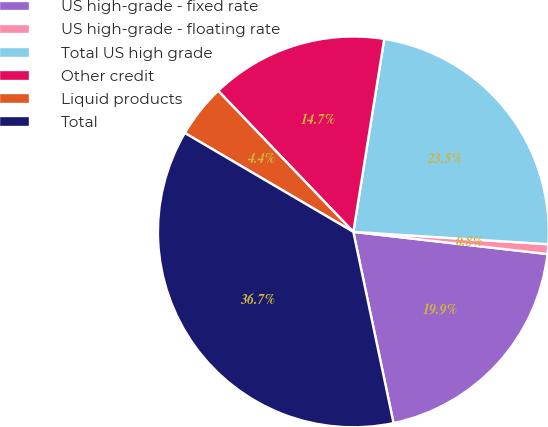Convert chart. <chart><loc_0><loc_0><loc_500><loc_500><pie_chart><fcel>US high-grade - fixed rate<fcel>US high-grade - floating rate<fcel>Total US high grade<fcel>Other credit<fcel>Liquid products<fcel>Total<nl><fcel>19.89%<fcel>0.8%<fcel>23.48%<fcel>14.69%<fcel>4.39%<fcel>36.74%<nl></chart> 